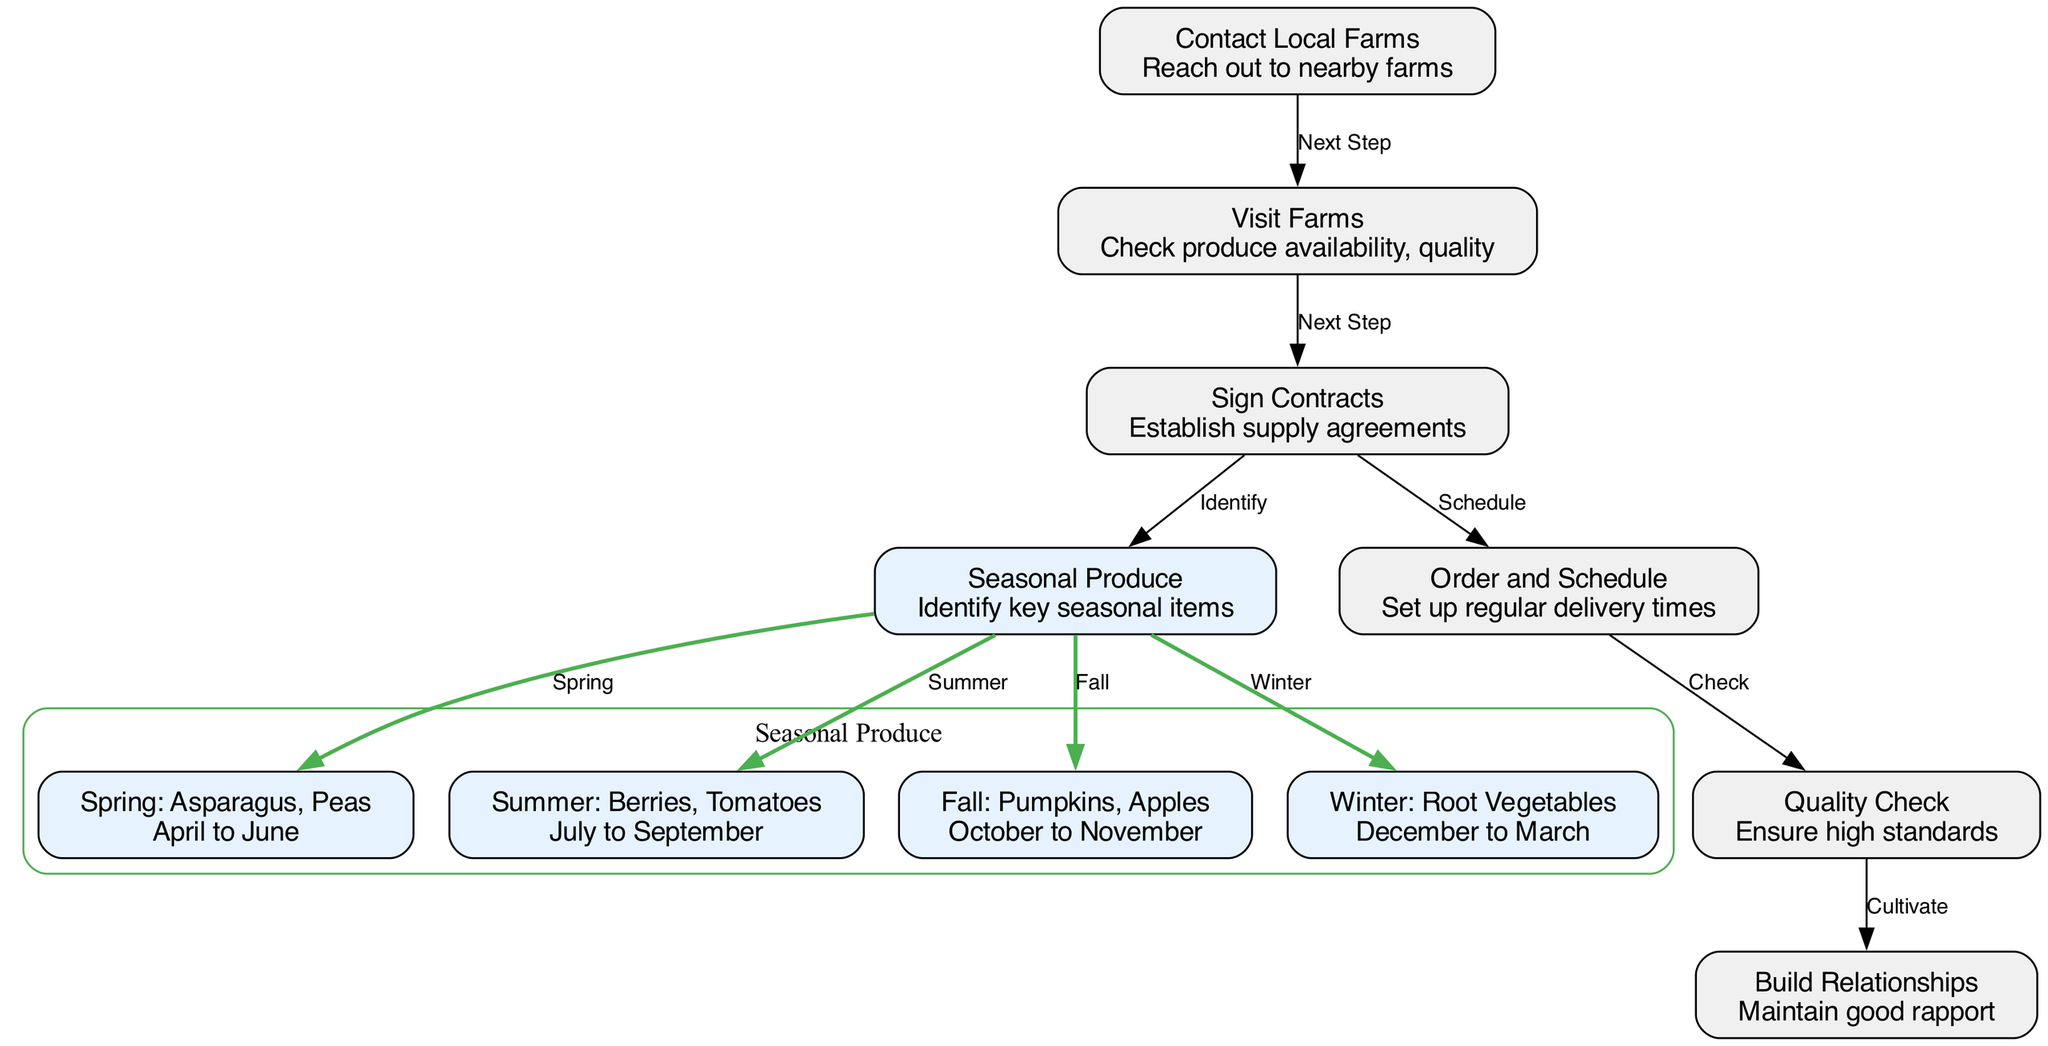What is the first step in sourcing fresh ingredients? The first step as indicated in the diagram is to "Contact Local Farms," where the aim is to reach out to nearby farms.
Answer: Contact Local Farms Which seasonal produce is identified in the fall? The fall seasonal produce identified in the diagram includes "Pumpkins" and "Apples," which are highlighted under the "Fall: Pumpkins, Apples" node.
Answer: Pumpkins, Apples How many nodes are there in total? By counting all distinct nodes in the diagram, we find a total of 10 nodes, which include actions and seasonal produce.
Answer: 10 What is the purpose of the "Quality Check" node? The "Quality Check" node's purpose is to ensure high standards for the produce received from local farms, indicating its importance in maintaining quality.
Answer: Ensure high standards What is the relationship between the "Contract Sign" node and the "Order and Schedule" node? The diagram shows a directed connection from "Contract Sign" to "Order and Schedule," indicating that scheduling occurs after signing contracts, as it establishes agreements to facilitate regular delivery.
Answer: Schedule What are the four types of seasonal produce identified in the diagram? The four types include "Spring: Asparagus, Peas," "Summer: Berries, Tomatoes," "Fall: Pumpkins, Apples," and "Winter: Root Vegetables." These are specifically categorized based on the seasons.
Answer: Spring: Asparagus, Peas; Summer: Berries, Tomatoes; Fall: Pumpkins, Apples; Winter: Root Vegetables Which node advises on maintaining a good rapport with farms? The node labeled "Build Relationships" indicates the importance of maintaining a good rapport with the farms to ensure a strong partnership in sourcing produce.
Answer: Build Relationships What action follows after completing the "Order and Schedule" step? After completing the "Order and Schedule" step, the next action is to perform a "Quality Check," which is essential to ensure the produce meets the required standards.
Answer: Quality Check 